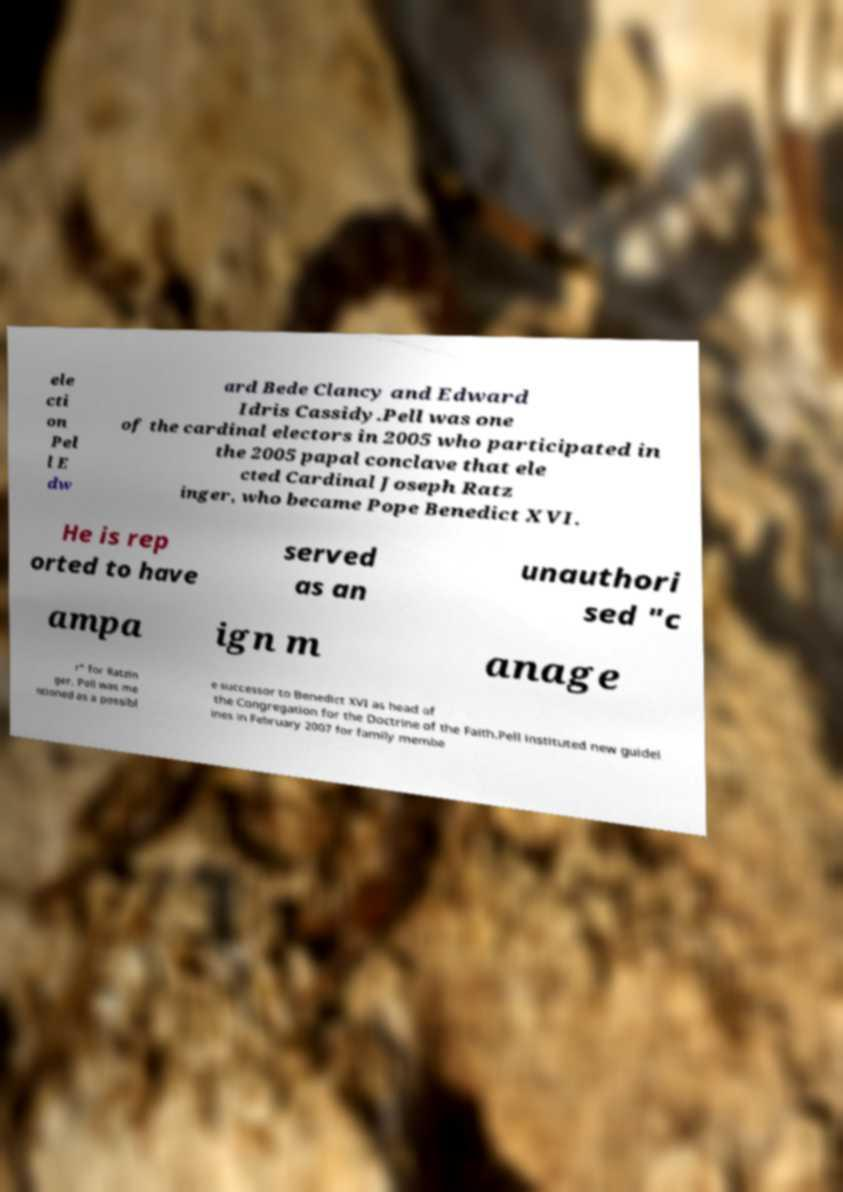Please identify and transcribe the text found in this image. ele cti on Pel l E dw ard Bede Clancy and Edward Idris Cassidy.Pell was one of the cardinal electors in 2005 who participated in the 2005 papal conclave that ele cted Cardinal Joseph Ratz inger, who became Pope Benedict XVI. He is rep orted to have served as an unauthori sed "c ampa ign m anage r" for Ratzin ger. Pell was me ntioned as a possibl e successor to Benedict XVI as head of the Congregation for the Doctrine of the Faith.Pell instituted new guidel ines in February 2007 for family membe 